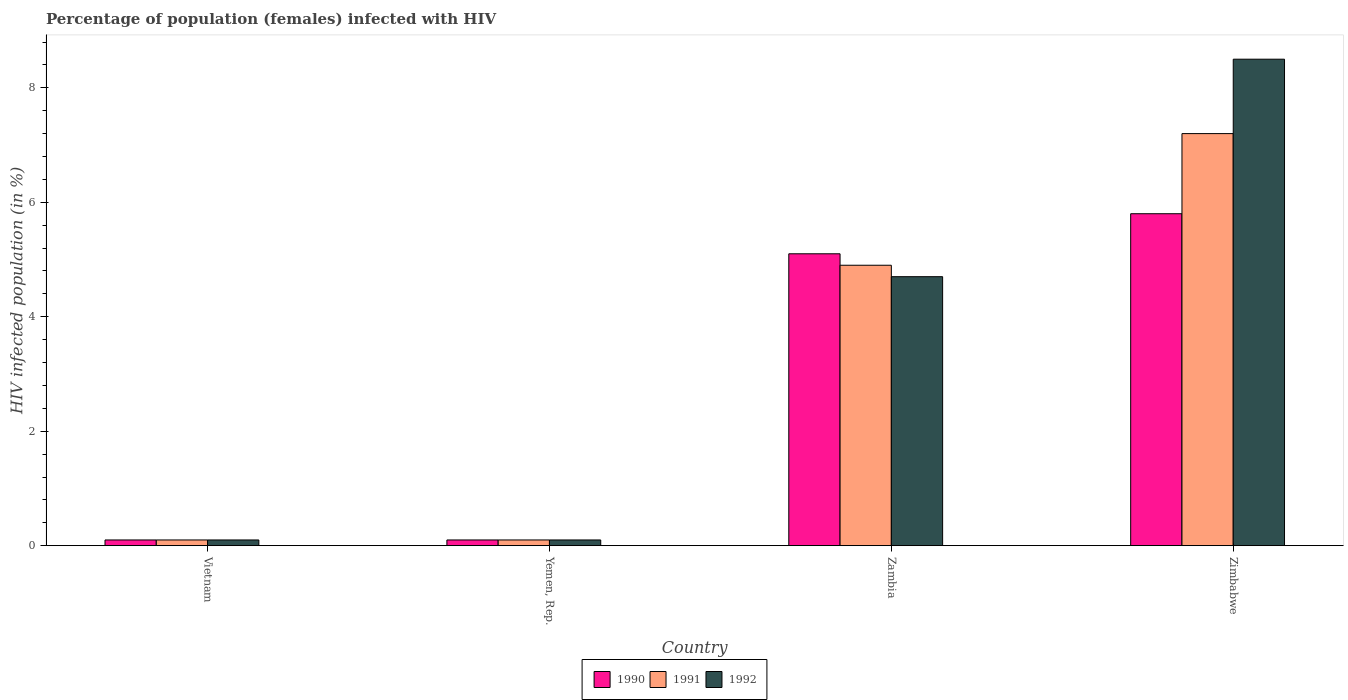How many different coloured bars are there?
Provide a short and direct response. 3. How many groups of bars are there?
Provide a short and direct response. 4. Are the number of bars per tick equal to the number of legend labels?
Make the answer very short. Yes. Are the number of bars on each tick of the X-axis equal?
Provide a succinct answer. Yes. How many bars are there on the 1st tick from the right?
Give a very brief answer. 3. What is the label of the 4th group of bars from the left?
Your answer should be very brief. Zimbabwe. In how many cases, is the number of bars for a given country not equal to the number of legend labels?
Keep it short and to the point. 0. What is the percentage of HIV infected female population in 1991 in Yemen, Rep.?
Your answer should be very brief. 0.1. Across all countries, what is the maximum percentage of HIV infected female population in 1991?
Make the answer very short. 7.2. In which country was the percentage of HIV infected female population in 1992 maximum?
Your answer should be compact. Zimbabwe. In which country was the percentage of HIV infected female population in 1992 minimum?
Provide a succinct answer. Vietnam. What is the total percentage of HIV infected female population in 1990 in the graph?
Your answer should be compact. 11.1. What is the difference between the percentage of HIV infected female population in 1990 in Yemen, Rep. and that in Zambia?
Your answer should be very brief. -5. What is the difference between the percentage of HIV infected female population in 1990 in Vietnam and the percentage of HIV infected female population in 1992 in Zambia?
Offer a very short reply. -4.6. What is the average percentage of HIV infected female population in 1990 per country?
Your answer should be compact. 2.77. In how many countries, is the percentage of HIV infected female population in 1992 greater than 8.4 %?
Provide a succinct answer. 1. What is the ratio of the percentage of HIV infected female population in 1992 in Yemen, Rep. to that in Zimbabwe?
Offer a terse response. 0.01. Is the difference between the percentage of HIV infected female population in 1990 in Vietnam and Zimbabwe greater than the difference between the percentage of HIV infected female population in 1992 in Vietnam and Zimbabwe?
Give a very brief answer. Yes. What is the difference between the highest and the second highest percentage of HIV infected female population in 1990?
Your answer should be very brief. -5. What is the difference between the highest and the lowest percentage of HIV infected female population in 1992?
Your answer should be very brief. 8.4. In how many countries, is the percentage of HIV infected female population in 1992 greater than the average percentage of HIV infected female population in 1992 taken over all countries?
Your answer should be very brief. 2. Are all the bars in the graph horizontal?
Ensure brevity in your answer.  No. How many countries are there in the graph?
Make the answer very short. 4. What is the difference between two consecutive major ticks on the Y-axis?
Offer a terse response. 2. Where does the legend appear in the graph?
Offer a terse response. Bottom center. How are the legend labels stacked?
Keep it short and to the point. Horizontal. What is the title of the graph?
Your response must be concise. Percentage of population (females) infected with HIV. What is the label or title of the Y-axis?
Provide a succinct answer. HIV infected population (in %). What is the HIV infected population (in %) in 1992 in Vietnam?
Give a very brief answer. 0.1. What is the HIV infected population (in %) of 1991 in Yemen, Rep.?
Your answer should be compact. 0.1. What is the HIV infected population (in %) in 1992 in Yemen, Rep.?
Ensure brevity in your answer.  0.1. What is the HIV infected population (in %) in 1991 in Zambia?
Ensure brevity in your answer.  4.9. What is the HIV infected population (in %) in 1992 in Zambia?
Provide a short and direct response. 4.7. Across all countries, what is the maximum HIV infected population (in %) in 1991?
Your response must be concise. 7.2. What is the total HIV infected population (in %) in 1990 in the graph?
Provide a succinct answer. 11.1. What is the total HIV infected population (in %) in 1991 in the graph?
Offer a terse response. 12.3. What is the difference between the HIV infected population (in %) in 1990 in Vietnam and that in Yemen, Rep.?
Provide a short and direct response. 0. What is the difference between the HIV infected population (in %) of 1992 in Vietnam and that in Yemen, Rep.?
Make the answer very short. 0. What is the difference between the HIV infected population (in %) of 1990 in Vietnam and that in Zambia?
Keep it short and to the point. -5. What is the difference between the HIV infected population (in %) of 1991 in Vietnam and that in Zambia?
Provide a short and direct response. -4.8. What is the difference between the HIV infected population (in %) in 1991 in Yemen, Rep. and that in Zambia?
Offer a very short reply. -4.8. What is the difference between the HIV infected population (in %) of 1992 in Yemen, Rep. and that in Zambia?
Offer a terse response. -4.6. What is the difference between the HIV infected population (in %) in 1991 in Zambia and that in Zimbabwe?
Keep it short and to the point. -2.3. What is the difference between the HIV infected population (in %) in 1990 in Vietnam and the HIV infected population (in %) in 1991 in Yemen, Rep.?
Your answer should be compact. 0. What is the difference between the HIV infected population (in %) in 1990 in Vietnam and the HIV infected population (in %) in 1992 in Zambia?
Offer a terse response. -4.6. What is the difference between the HIV infected population (in %) of 1990 in Vietnam and the HIV infected population (in %) of 1992 in Zimbabwe?
Make the answer very short. -8.4. What is the difference between the HIV infected population (in %) in 1991 in Yemen, Rep. and the HIV infected population (in %) in 1992 in Zambia?
Offer a terse response. -4.6. What is the difference between the HIV infected population (in %) of 1990 in Yemen, Rep. and the HIV infected population (in %) of 1991 in Zimbabwe?
Offer a very short reply. -7.1. What is the difference between the HIV infected population (in %) of 1990 in Yemen, Rep. and the HIV infected population (in %) of 1992 in Zimbabwe?
Make the answer very short. -8.4. What is the difference between the HIV infected population (in %) of 1991 in Yemen, Rep. and the HIV infected population (in %) of 1992 in Zimbabwe?
Provide a succinct answer. -8.4. What is the difference between the HIV infected population (in %) in 1990 in Zambia and the HIV infected population (in %) in 1991 in Zimbabwe?
Your response must be concise. -2.1. What is the difference between the HIV infected population (in %) in 1990 in Zambia and the HIV infected population (in %) in 1992 in Zimbabwe?
Make the answer very short. -3.4. What is the average HIV infected population (in %) of 1990 per country?
Provide a short and direct response. 2.77. What is the average HIV infected population (in %) in 1991 per country?
Your answer should be compact. 3.08. What is the average HIV infected population (in %) in 1992 per country?
Ensure brevity in your answer.  3.35. What is the difference between the HIV infected population (in %) of 1990 and HIV infected population (in %) of 1991 in Vietnam?
Offer a very short reply. 0. What is the difference between the HIV infected population (in %) in 1990 and HIV infected population (in %) in 1992 in Vietnam?
Offer a terse response. 0. What is the difference between the HIV infected population (in %) in 1991 and HIV infected population (in %) in 1992 in Yemen, Rep.?
Your response must be concise. 0. What is the difference between the HIV infected population (in %) of 1990 and HIV infected population (in %) of 1991 in Zambia?
Provide a succinct answer. 0.2. What is the difference between the HIV infected population (in %) in 1990 and HIV infected population (in %) in 1992 in Zambia?
Your answer should be compact. 0.4. What is the difference between the HIV infected population (in %) of 1991 and HIV infected population (in %) of 1992 in Zambia?
Give a very brief answer. 0.2. What is the difference between the HIV infected population (in %) of 1990 and HIV infected population (in %) of 1991 in Zimbabwe?
Provide a succinct answer. -1.4. What is the difference between the HIV infected population (in %) in 1991 and HIV infected population (in %) in 1992 in Zimbabwe?
Keep it short and to the point. -1.3. What is the ratio of the HIV infected population (in %) of 1990 in Vietnam to that in Yemen, Rep.?
Your response must be concise. 1. What is the ratio of the HIV infected population (in %) of 1991 in Vietnam to that in Yemen, Rep.?
Offer a very short reply. 1. What is the ratio of the HIV infected population (in %) in 1992 in Vietnam to that in Yemen, Rep.?
Provide a succinct answer. 1. What is the ratio of the HIV infected population (in %) of 1990 in Vietnam to that in Zambia?
Provide a succinct answer. 0.02. What is the ratio of the HIV infected population (in %) in 1991 in Vietnam to that in Zambia?
Ensure brevity in your answer.  0.02. What is the ratio of the HIV infected population (in %) of 1992 in Vietnam to that in Zambia?
Provide a short and direct response. 0.02. What is the ratio of the HIV infected population (in %) in 1990 in Vietnam to that in Zimbabwe?
Give a very brief answer. 0.02. What is the ratio of the HIV infected population (in %) in 1991 in Vietnam to that in Zimbabwe?
Ensure brevity in your answer.  0.01. What is the ratio of the HIV infected population (in %) of 1992 in Vietnam to that in Zimbabwe?
Provide a succinct answer. 0.01. What is the ratio of the HIV infected population (in %) in 1990 in Yemen, Rep. to that in Zambia?
Your answer should be very brief. 0.02. What is the ratio of the HIV infected population (in %) in 1991 in Yemen, Rep. to that in Zambia?
Offer a terse response. 0.02. What is the ratio of the HIV infected population (in %) in 1992 in Yemen, Rep. to that in Zambia?
Your answer should be very brief. 0.02. What is the ratio of the HIV infected population (in %) of 1990 in Yemen, Rep. to that in Zimbabwe?
Your answer should be very brief. 0.02. What is the ratio of the HIV infected population (in %) of 1991 in Yemen, Rep. to that in Zimbabwe?
Your answer should be compact. 0.01. What is the ratio of the HIV infected population (in %) in 1992 in Yemen, Rep. to that in Zimbabwe?
Make the answer very short. 0.01. What is the ratio of the HIV infected population (in %) of 1990 in Zambia to that in Zimbabwe?
Keep it short and to the point. 0.88. What is the ratio of the HIV infected population (in %) in 1991 in Zambia to that in Zimbabwe?
Offer a terse response. 0.68. What is the ratio of the HIV infected population (in %) of 1992 in Zambia to that in Zimbabwe?
Your response must be concise. 0.55. What is the difference between the highest and the second highest HIV infected population (in %) of 1990?
Your response must be concise. 0.7. What is the difference between the highest and the second highest HIV infected population (in %) in 1991?
Offer a very short reply. 2.3. What is the difference between the highest and the lowest HIV infected population (in %) of 1992?
Provide a short and direct response. 8.4. 